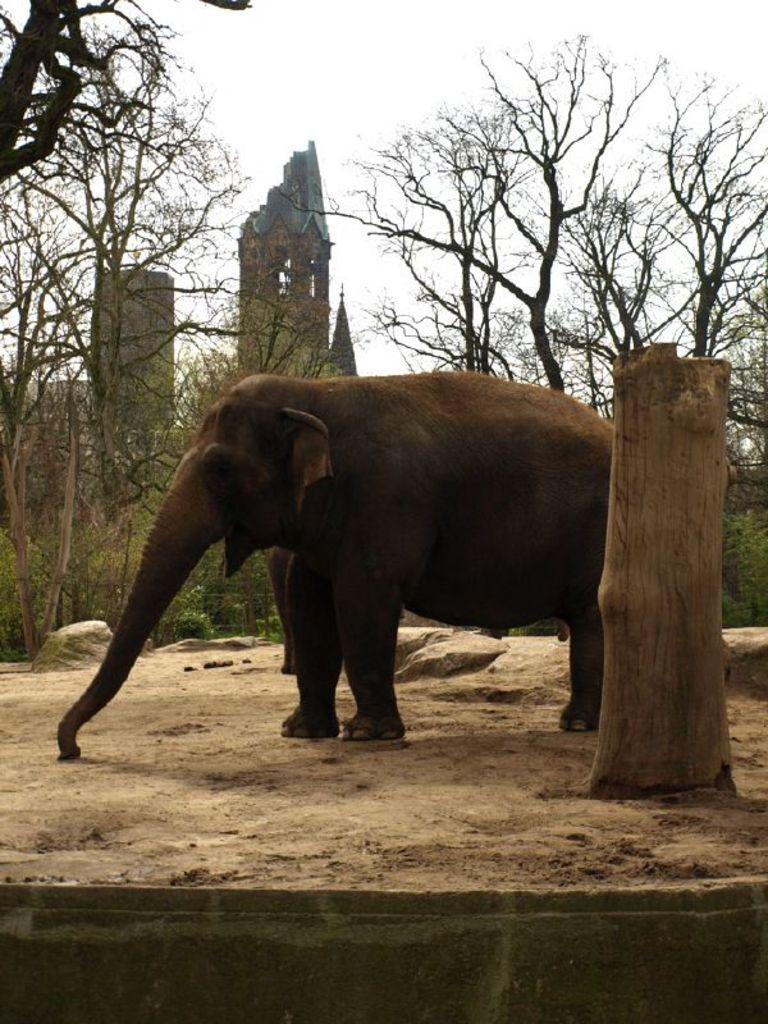What animal is present in the image? There is an elephant in the image. What is in front of the elephant? There is a wooden stem of a tree in front of the elephant. What can be seen in the background of the image? There are trees, a building, and the sky visible in the background of the image. What type of loaf is being used as a chess piece in the image? There is no loaf or chess set present in the image; it features an elephant and a wooden stem of a tree. What kind of hall is visible in the background of the image? There is no hall visible in the background of the image; it features trees, a building, and the sky. 